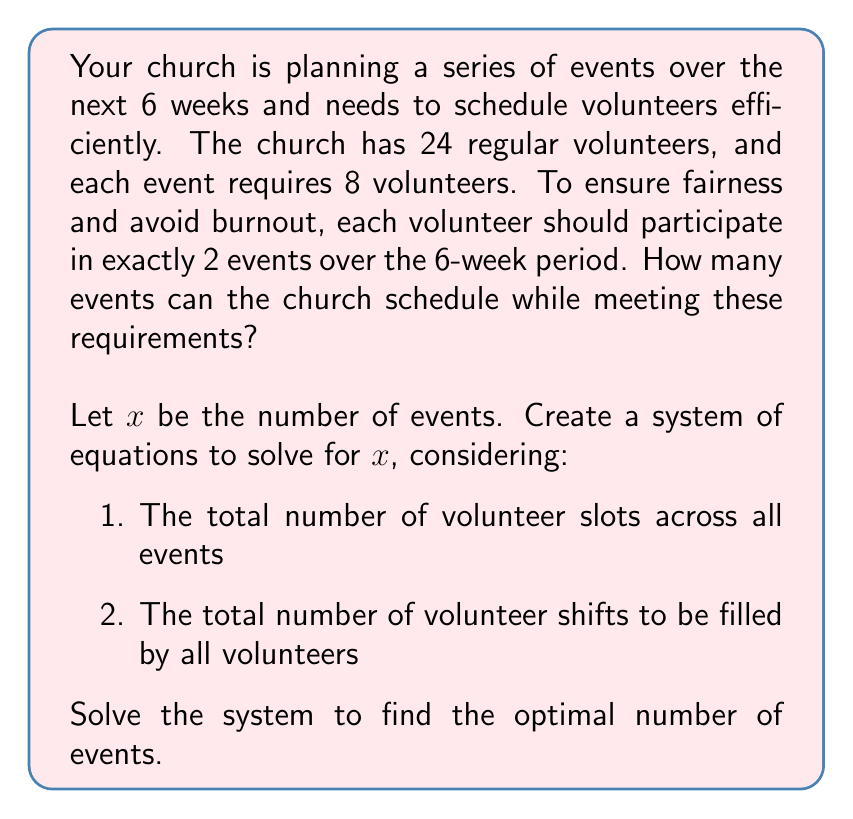Provide a solution to this math problem. Let's approach this step-by-step:

1) First, let's define our variables:
   $x$ = number of events
   24 = total number of volunteers
   8 = number of volunteers required per event
   2 = number of events each volunteer should participate in

2) Now, let's create our system of equations:

   Equation 1: Total volunteer slots across all events
   $$8x = \text{total volunteer slots}$$

   Equation 2: Total volunteer shifts to be filled
   $$24 \cdot 2 = \text{total volunteer shifts}$$

3) These two quantities should be equal for the system to work:

   $$8x = 24 \cdot 2$$

4) Let's solve this equation:

   $$8x = 48$$
   $$x = 48 \div 8 = 6$$

5) Let's verify our solution:
   - 6 events, each requiring 8 volunteers: $6 \cdot 8 = 48$ total volunteer slots
   - 24 volunteers, each volunteering twice: $24 \cdot 2 = 48$ total volunteer shifts

6) This solution satisfies our constraints:
   - Each event has 8 volunteers
   - Each volunteer participates in exactly 2 events
   - All 24 volunteers are utilized

Therefore, the church can schedule 6 events while meeting all the requirements.
Answer: The church can schedule 6 events. 